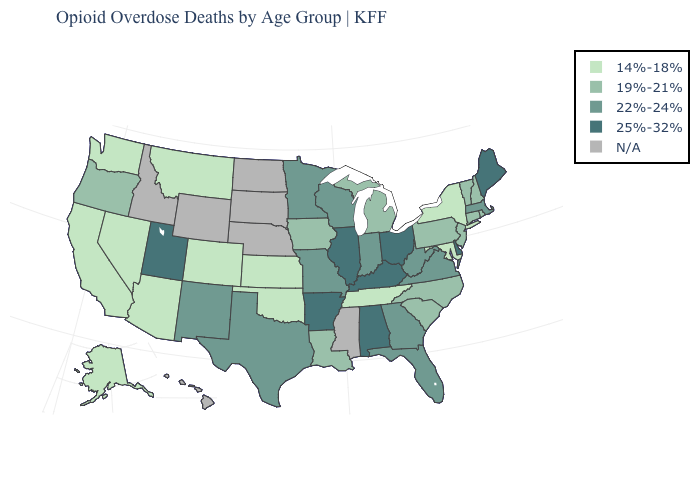Name the states that have a value in the range N/A?
Concise answer only. Hawaii, Idaho, Mississippi, Nebraska, North Dakota, South Dakota, Wyoming. What is the value of New Jersey?
Write a very short answer. 19%-21%. What is the value of Illinois?
Answer briefly. 25%-32%. Name the states that have a value in the range 22%-24%?
Concise answer only. Florida, Georgia, Indiana, Massachusetts, Minnesota, Missouri, New Mexico, Texas, Virginia, West Virginia, Wisconsin. Name the states that have a value in the range 22%-24%?
Be succinct. Florida, Georgia, Indiana, Massachusetts, Minnesota, Missouri, New Mexico, Texas, Virginia, West Virginia, Wisconsin. Among the states that border Utah , which have the lowest value?
Concise answer only. Arizona, Colorado, Nevada. How many symbols are there in the legend?
Quick response, please. 5. Name the states that have a value in the range 22%-24%?
Keep it brief. Florida, Georgia, Indiana, Massachusetts, Minnesota, Missouri, New Mexico, Texas, Virginia, West Virginia, Wisconsin. Does the map have missing data?
Give a very brief answer. Yes. Among the states that border Arkansas , does Louisiana have the lowest value?
Quick response, please. No. Does the map have missing data?
Keep it brief. Yes. What is the highest value in the MidWest ?
Concise answer only. 25%-32%. Does New York have the lowest value in the USA?
Quick response, please. Yes. Which states have the highest value in the USA?
Keep it brief. Alabama, Arkansas, Delaware, Illinois, Kentucky, Maine, Ohio, Utah. Name the states that have a value in the range 25%-32%?
Quick response, please. Alabama, Arkansas, Delaware, Illinois, Kentucky, Maine, Ohio, Utah. 